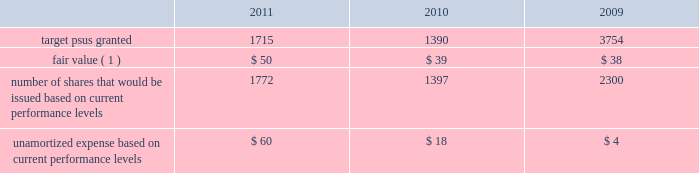Performance share awards the vesting of psas is contingent upon meeting various individual , divisional or company-wide performance conditions , including revenue generation or growth in revenue , pretax income or earnings per share over a one- to five-year period .
The performance conditions are not considered in the determination of the grant date fair value for these awards .
The fair value of psas is based upon the market price of the aon common stock at the date of grant .
Compensation expense is recognized over the performance period , and in certain cases an additional vesting period , based on management 2019s estimate of the number of units expected to vest .
Compensation expense is adjusted to reflect the actual number of shares issued at the end of the programs .
The actual issuance of shares may range from 0-200% ( 0-200 % ) of the target number of psas granted , based on the plan .
Dividend equivalents are not paid on psas .
Information regarding psas granted during the years ended december 31 , 2011 , 2010 and 2009 follows ( shares in thousands , dollars in millions , except fair value ) : .
( 1 ) represents per share weighted average fair value of award at date of grant .
During 2011 , the company issued approximately 1.2 million shares in connection with the 2008 leadership performance plan ( 2018 2018lpp 2019 2019 ) cycle and 0.3 million shares related to a 2006 performance plan .
During 2010 , the company issued approximately 1.6 million shares in connection with the completion of the 2007 lpp cycle and 84000 shares related to other performance plans .
Stock options options to purchase common stock are granted to certain employees at fair value on the date of grant .
Commencing in 2010 , the company ceased granting new stock options with the exception of historical contractual commitments .
Generally , employees are required to complete two continuous years of service before the options begin to vest in increments until the completion of a 4-year period of continuous employment , although a number of options were granted that require five continuous years of service before the options are fully vested .
Options issued under the lpp program vest ratable over 3 years with a six year term .
The maximum contractual term on stock options is generally ten years from the date of grant .
Aon uses a lattice-binomial option-pricing model to value stock options .
Lattice-based option valuation models use a range of assumptions over the expected term of the options .
Expected volatilities are based on the average of the historical volatility of aon 2019s stock price and the implied volatility of traded options and aon 2019s stock .
The valuation model stratifies employees between those receiving lpp options , special stock plan ( 2018 2018ssp 2019 2019 ) options , and all other option grants .
The company believes that this stratification better represents prospective stock option exercise patterns .
The expected dividend yield assumption is based on the company 2019s historical and expected future dividend rate .
The risk-free rate for periods within the contractual life of the option is based on the u.s .
Treasury yield curve in effect at the time of grant .
The expected life of employee stock options represents the weighted-average period stock options are expected to remain outstanding and is a derived output of the lattice-binomial model. .
What is the lowest value of unamortized expense during this period? 
Rationale: it is the minimum value of unamortized expense .
Computations: table_min(unamortized expense based on current performance levels, none)
Answer: 4.0. 